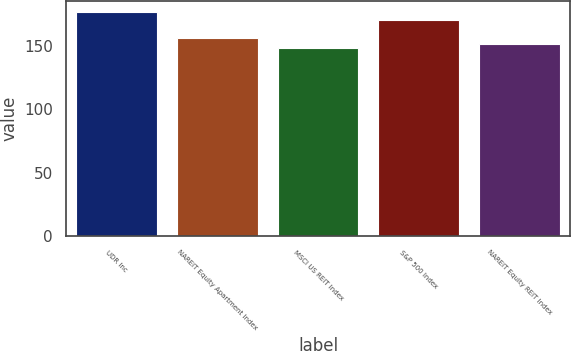Convert chart. <chart><loc_0><loc_0><loc_500><loc_500><bar_chart><fcel>UDR Inc<fcel>NAREIT Equity Apartment Index<fcel>MSCI US REIT Index<fcel>S&P 500 Index<fcel>NAREIT Equity REIT Index<nl><fcel>176.68<fcel>156.88<fcel>148.75<fcel>170.84<fcel>151.54<nl></chart> 